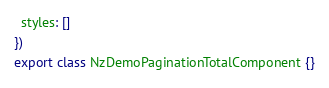<code> <loc_0><loc_0><loc_500><loc_500><_TypeScript_>  styles: []
})
export class NzDemoPaginationTotalComponent {}
</code> 